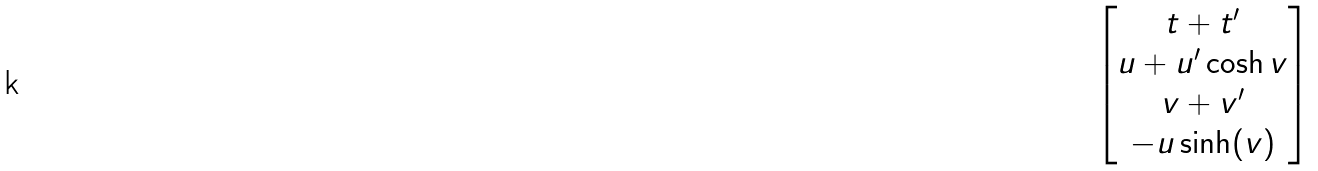Convert formula to latex. <formula><loc_0><loc_0><loc_500><loc_500>\begin{bmatrix} t + t ^ { \prime } \\ u + u ^ { \prime } \cosh v \\ v + v ^ { \prime } \\ - u \sinh ( v ) \end{bmatrix}</formula> 